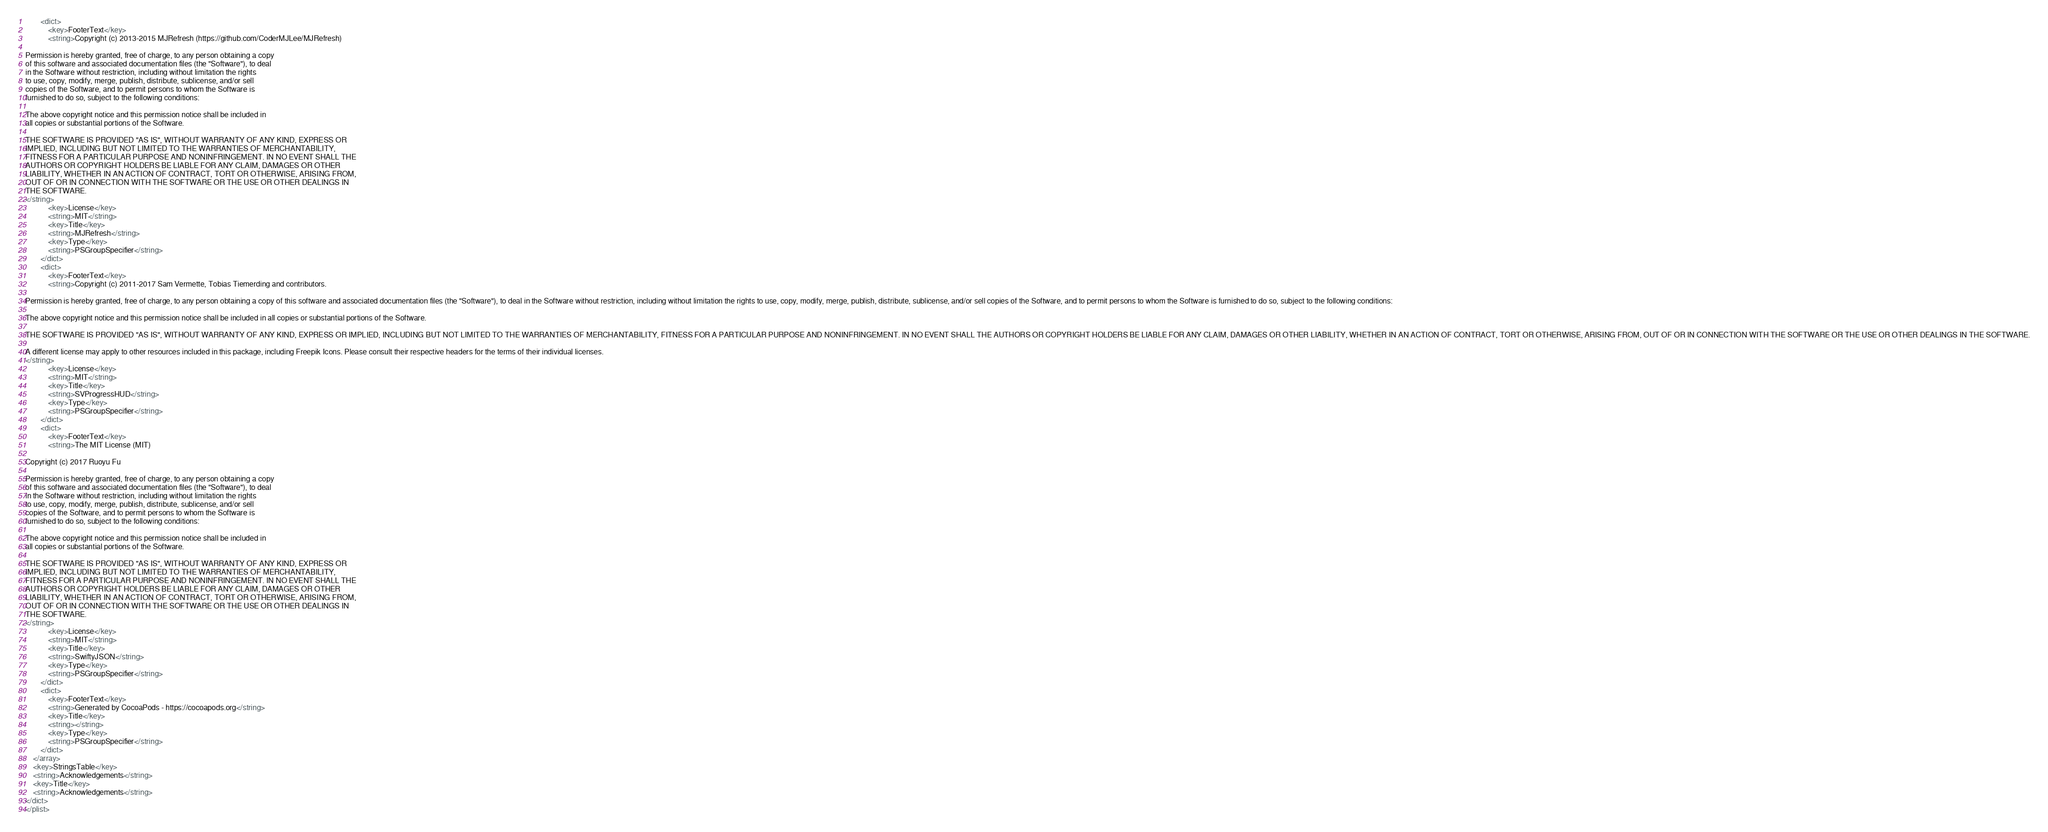Convert code to text. <code><loc_0><loc_0><loc_500><loc_500><_XML_>		<dict>
			<key>FooterText</key>
			<string>Copyright (c) 2013-2015 MJRefresh (https://github.com/CoderMJLee/MJRefresh)

Permission is hereby granted, free of charge, to any person obtaining a copy
of this software and associated documentation files (the "Software"), to deal
in the Software without restriction, including without limitation the rights
to use, copy, modify, merge, publish, distribute, sublicense, and/or sell
copies of the Software, and to permit persons to whom the Software is
furnished to do so, subject to the following conditions:

The above copyright notice and this permission notice shall be included in
all copies or substantial portions of the Software.

THE SOFTWARE IS PROVIDED "AS IS", WITHOUT WARRANTY OF ANY KIND, EXPRESS OR
IMPLIED, INCLUDING BUT NOT LIMITED TO THE WARRANTIES OF MERCHANTABILITY,
FITNESS FOR A PARTICULAR PURPOSE AND NONINFRINGEMENT. IN NO EVENT SHALL THE
AUTHORS OR COPYRIGHT HOLDERS BE LIABLE FOR ANY CLAIM, DAMAGES OR OTHER
LIABILITY, WHETHER IN AN ACTION OF CONTRACT, TORT OR OTHERWISE, ARISING FROM,
OUT OF OR IN CONNECTION WITH THE SOFTWARE OR THE USE OR OTHER DEALINGS IN
THE SOFTWARE.
</string>
			<key>License</key>
			<string>MIT</string>
			<key>Title</key>
			<string>MJRefresh</string>
			<key>Type</key>
			<string>PSGroupSpecifier</string>
		</dict>
		<dict>
			<key>FooterText</key>
			<string>Copyright (c) 2011-2017 Sam Vermette, Tobias Tiemerding and contributors.

Permission is hereby granted, free of charge, to any person obtaining a copy of this software and associated documentation files (the "Software"), to deal in the Software without restriction, including without limitation the rights to use, copy, modify, merge, publish, distribute, sublicense, and/or sell copies of the Software, and to permit persons to whom the Software is furnished to do so, subject to the following conditions:

The above copyright notice and this permission notice shall be included in all copies or substantial portions of the Software.

THE SOFTWARE IS PROVIDED "AS IS", WITHOUT WARRANTY OF ANY KIND, EXPRESS OR IMPLIED, INCLUDING BUT NOT LIMITED TO THE WARRANTIES OF MERCHANTABILITY, FITNESS FOR A PARTICULAR PURPOSE AND NONINFRINGEMENT. IN NO EVENT SHALL THE AUTHORS OR COPYRIGHT HOLDERS BE LIABLE FOR ANY CLAIM, DAMAGES OR OTHER LIABILITY, WHETHER IN AN ACTION OF CONTRACT, TORT OR OTHERWISE, ARISING FROM, OUT OF OR IN CONNECTION WITH THE SOFTWARE OR THE USE OR OTHER DEALINGS IN THE SOFTWARE.

A different license may apply to other resources included in this package, including Freepik Icons. Please consult their respective headers for the terms of their individual licenses.
</string>
			<key>License</key>
			<string>MIT</string>
			<key>Title</key>
			<string>SVProgressHUD</string>
			<key>Type</key>
			<string>PSGroupSpecifier</string>
		</dict>
		<dict>
			<key>FooterText</key>
			<string>The MIT License (MIT)

Copyright (c) 2017 Ruoyu Fu

Permission is hereby granted, free of charge, to any person obtaining a copy
of this software and associated documentation files (the "Software"), to deal
in the Software without restriction, including without limitation the rights
to use, copy, modify, merge, publish, distribute, sublicense, and/or sell
copies of the Software, and to permit persons to whom the Software is
furnished to do so, subject to the following conditions:

The above copyright notice and this permission notice shall be included in
all copies or substantial portions of the Software.

THE SOFTWARE IS PROVIDED "AS IS", WITHOUT WARRANTY OF ANY KIND, EXPRESS OR
IMPLIED, INCLUDING BUT NOT LIMITED TO THE WARRANTIES OF MERCHANTABILITY,
FITNESS FOR A PARTICULAR PURPOSE AND NONINFRINGEMENT. IN NO EVENT SHALL THE
AUTHORS OR COPYRIGHT HOLDERS BE LIABLE FOR ANY CLAIM, DAMAGES OR OTHER
LIABILITY, WHETHER IN AN ACTION OF CONTRACT, TORT OR OTHERWISE, ARISING FROM,
OUT OF OR IN CONNECTION WITH THE SOFTWARE OR THE USE OR OTHER DEALINGS IN
THE SOFTWARE.
</string>
			<key>License</key>
			<string>MIT</string>
			<key>Title</key>
			<string>SwiftyJSON</string>
			<key>Type</key>
			<string>PSGroupSpecifier</string>
		</dict>
		<dict>
			<key>FooterText</key>
			<string>Generated by CocoaPods - https://cocoapods.org</string>
			<key>Title</key>
			<string></string>
			<key>Type</key>
			<string>PSGroupSpecifier</string>
		</dict>
	</array>
	<key>StringsTable</key>
	<string>Acknowledgements</string>
	<key>Title</key>
	<string>Acknowledgements</string>
</dict>
</plist>
</code> 